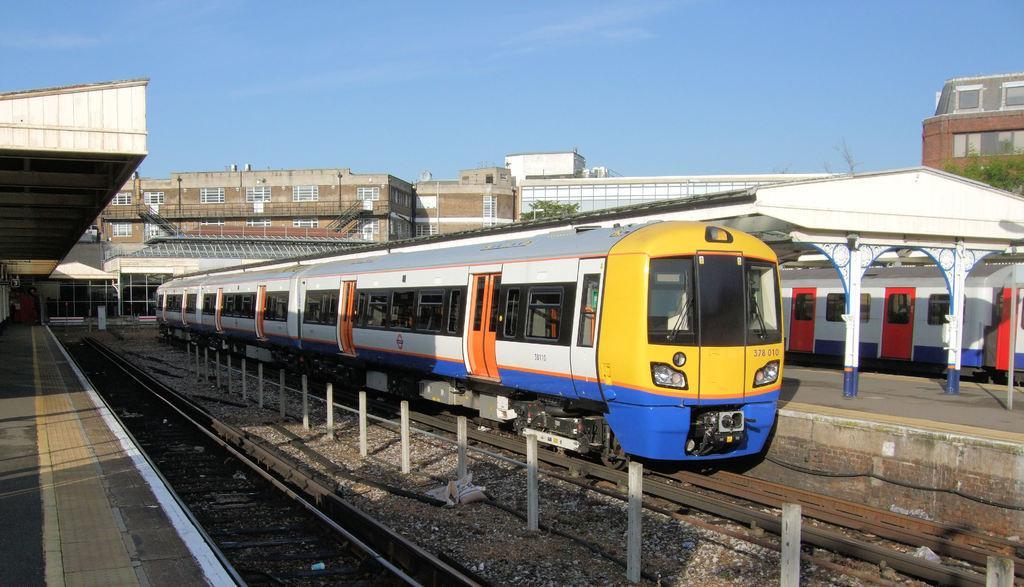Please provide a concise description of this image. In the center of the image there is a train on the track. In the background there are buildings, trees and sky. At the bottom there is a railway track. 